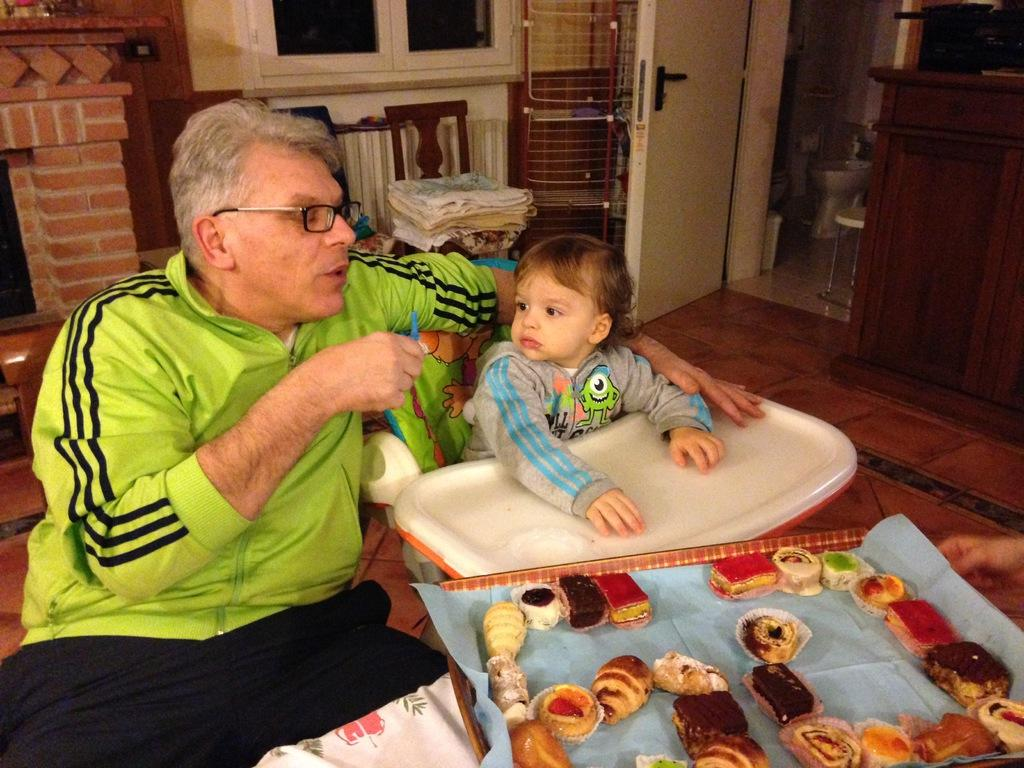Who is present in the image? There is a man in the image. Where is the man located in the image? The man is on the left side of the image. What is the small baby doing in the image? The small baby is in a sitter in the image. What architectural features can be seen in the image? There are doors and windows in the image. Where are the doors and windows located in the image? The doors and windows are at the top side of the image. What type of income can be seen in the image? There is no reference to income in the image. What type of card is being used by the man in the image? There is no card present in the image. 